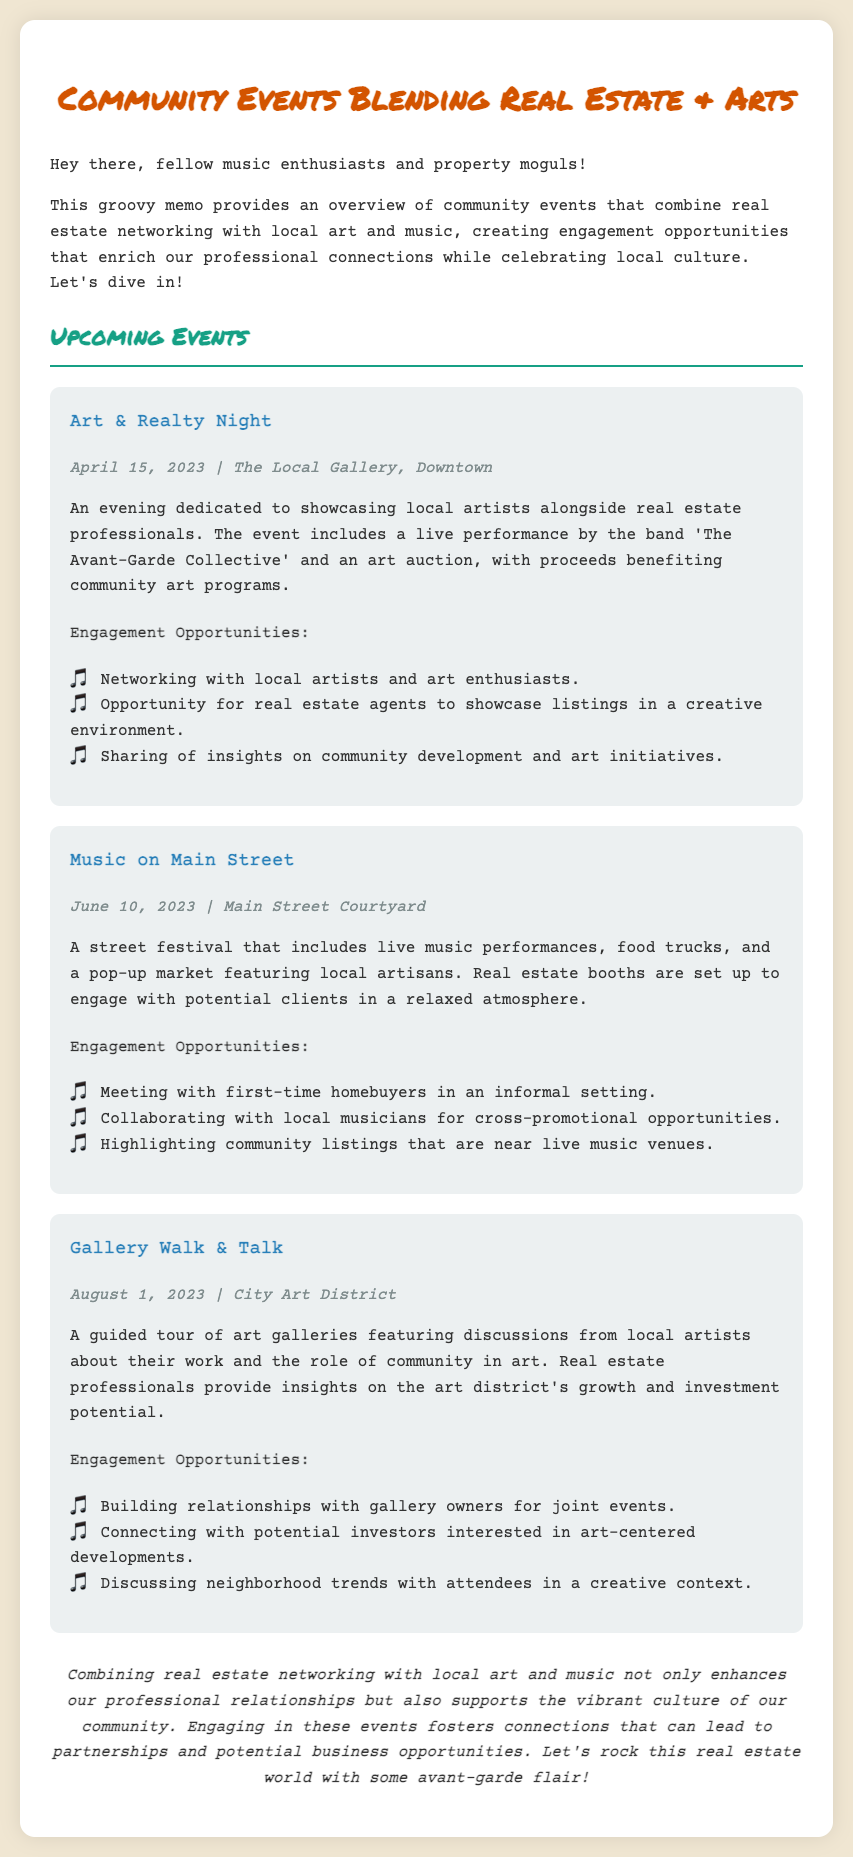what is the title of the memo? The title of the memo is presented prominently at the top of the document.
Answer: Community Events Blending Real Estate & Arts when is the Art & Realty Night event? The date of the Art & Realty Night event is mentioned in its details.
Answer: April 15, 2023 where is the Music on Main Street event located? The location of the Music on Main Street event is specified in the document.
Answer: Main Street Courtyard who performs at the Art & Realty Night? The name of the band performing at the Art & Realty Night is given in the event description.
Answer: The Avant-Garde Collective what engagement opportunity involves first-time homebuyers? This engagement opportunity is specifically mentioned under the Music on Main Street event.
Answer: Meeting with first-time homebuyers in an informal setting what is the focus of the Gallery Walk & Talk event? The focus of the Gallery Walk & Talk event is indicated in the description of the event.
Answer: A guided tour of art galleries how does combining real estate with local art benefit professionals? The conclusion of the memo discusses the benefits of this combination.
Answer: Enhances professional relationships what type of event is Music on Main Street? The overall nature of the event is described in the document.
Answer: A street festival 